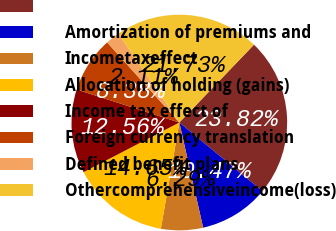Convert chart to OTSL. <chart><loc_0><loc_0><loc_500><loc_500><pie_chart><ecel><fcel>Amortization of premiums and<fcel>Incometaxeffect<fcel>Allocation of holding (gains)<fcel>Income tax effect of<fcel>Foreign currency translation<fcel>Defined benefit plans<fcel>Othercomprehensiveincome(loss)<nl><fcel>23.82%<fcel>10.47%<fcel>6.29%<fcel>14.65%<fcel>12.56%<fcel>8.38%<fcel>2.11%<fcel>21.73%<nl></chart> 